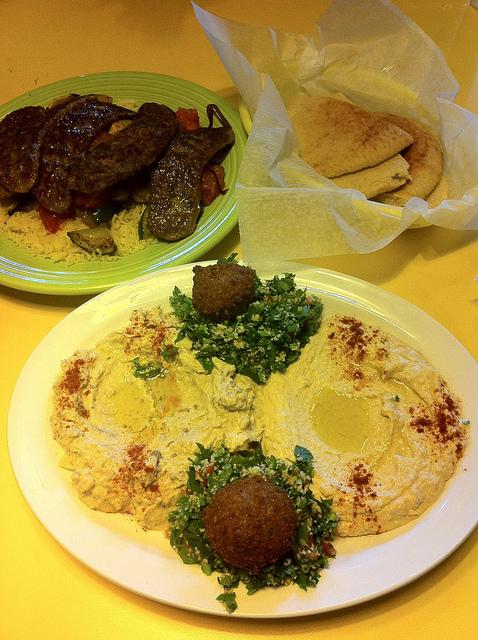Is there a white plate?
Be succinct. Yes. What is mainly featured?
Be succinct. Food. Is this Arabic food?
Be succinct. Yes. 